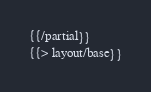Convert code to text. <code><loc_0><loc_0><loc_500><loc_500><_HTML_>{{/partial}}
{{> layout/base}}
</code> 